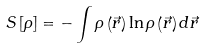<formula> <loc_0><loc_0><loc_500><loc_500>S \left [ \rho \right ] = - \int \rho \left ( \vec { r } \right ) \ln \rho \left ( \vec { r } \right ) d \vec { r }</formula> 